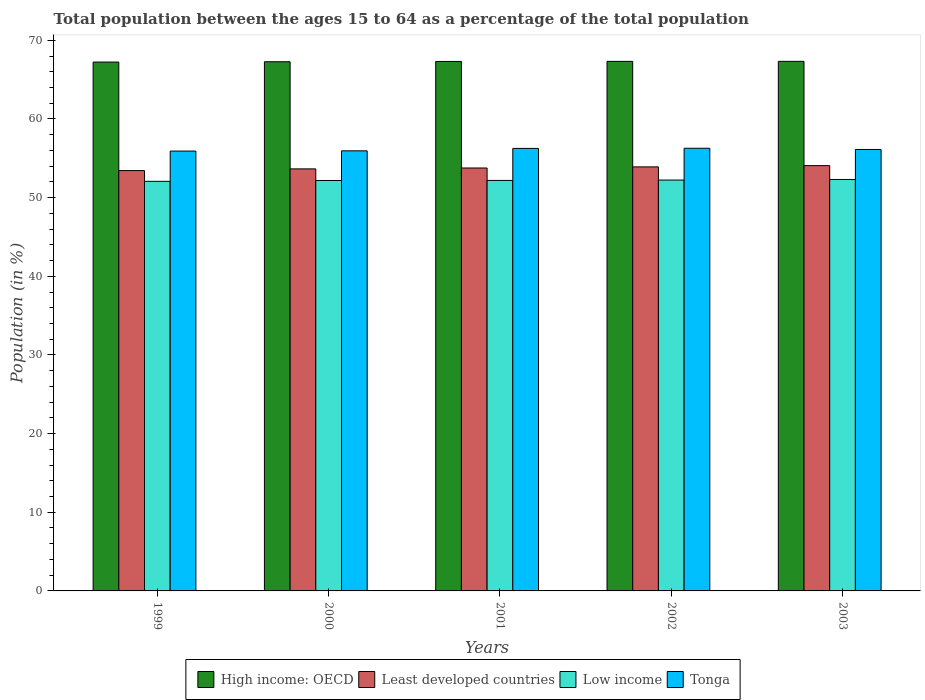How many groups of bars are there?
Offer a terse response. 5. Are the number of bars per tick equal to the number of legend labels?
Make the answer very short. Yes. How many bars are there on the 1st tick from the left?
Offer a very short reply. 4. In how many cases, is the number of bars for a given year not equal to the number of legend labels?
Provide a short and direct response. 0. What is the percentage of the population ages 15 to 64 in High income: OECD in 1999?
Offer a very short reply. 67.24. Across all years, what is the maximum percentage of the population ages 15 to 64 in Tonga?
Make the answer very short. 56.28. Across all years, what is the minimum percentage of the population ages 15 to 64 in Tonga?
Make the answer very short. 55.92. In which year was the percentage of the population ages 15 to 64 in Least developed countries maximum?
Provide a succinct answer. 2003. In which year was the percentage of the population ages 15 to 64 in Low income minimum?
Offer a very short reply. 1999. What is the total percentage of the population ages 15 to 64 in Least developed countries in the graph?
Your answer should be compact. 268.85. What is the difference between the percentage of the population ages 15 to 64 in Tonga in 2000 and that in 2002?
Your response must be concise. -0.33. What is the difference between the percentage of the population ages 15 to 64 in Least developed countries in 2001 and the percentage of the population ages 15 to 64 in Tonga in 2002?
Provide a succinct answer. -2.51. What is the average percentage of the population ages 15 to 64 in High income: OECD per year?
Ensure brevity in your answer.  67.3. In the year 2000, what is the difference between the percentage of the population ages 15 to 64 in Low income and percentage of the population ages 15 to 64 in High income: OECD?
Keep it short and to the point. -15.1. In how many years, is the percentage of the population ages 15 to 64 in Tonga greater than 66?
Ensure brevity in your answer.  0. What is the ratio of the percentage of the population ages 15 to 64 in High income: OECD in 1999 to that in 2000?
Provide a succinct answer. 1. Is the percentage of the population ages 15 to 64 in Tonga in 2002 less than that in 2003?
Keep it short and to the point. No. Is the difference between the percentage of the population ages 15 to 64 in Low income in 2002 and 2003 greater than the difference between the percentage of the population ages 15 to 64 in High income: OECD in 2002 and 2003?
Offer a terse response. No. What is the difference between the highest and the second highest percentage of the population ages 15 to 64 in Tonga?
Your answer should be compact. 0.02. What is the difference between the highest and the lowest percentage of the population ages 15 to 64 in High income: OECD?
Offer a very short reply. 0.09. In how many years, is the percentage of the population ages 15 to 64 in Least developed countries greater than the average percentage of the population ages 15 to 64 in Least developed countries taken over all years?
Your answer should be compact. 2. Is it the case that in every year, the sum of the percentage of the population ages 15 to 64 in Least developed countries and percentage of the population ages 15 to 64 in Tonga is greater than the sum of percentage of the population ages 15 to 64 in Low income and percentage of the population ages 15 to 64 in High income: OECD?
Your answer should be compact. No. What does the 1st bar from the left in 1999 represents?
Ensure brevity in your answer.  High income: OECD. What does the 2nd bar from the right in 2003 represents?
Ensure brevity in your answer.  Low income. What is the difference between two consecutive major ticks on the Y-axis?
Offer a very short reply. 10. Are the values on the major ticks of Y-axis written in scientific E-notation?
Make the answer very short. No. Does the graph contain any zero values?
Ensure brevity in your answer.  No. How many legend labels are there?
Ensure brevity in your answer.  4. How are the legend labels stacked?
Offer a very short reply. Horizontal. What is the title of the graph?
Provide a succinct answer. Total population between the ages 15 to 64 as a percentage of the total population. Does "Liberia" appear as one of the legend labels in the graph?
Offer a very short reply. No. What is the label or title of the X-axis?
Provide a short and direct response. Years. What is the Population (in %) in High income: OECD in 1999?
Make the answer very short. 67.24. What is the Population (in %) in Least developed countries in 1999?
Give a very brief answer. 53.44. What is the Population (in %) in Low income in 1999?
Provide a succinct answer. 52.08. What is the Population (in %) in Tonga in 1999?
Offer a very short reply. 55.92. What is the Population (in %) of High income: OECD in 2000?
Provide a succinct answer. 67.28. What is the Population (in %) of Least developed countries in 2000?
Ensure brevity in your answer.  53.66. What is the Population (in %) in Low income in 2000?
Make the answer very short. 52.18. What is the Population (in %) in Tonga in 2000?
Your answer should be very brief. 55.95. What is the Population (in %) in High income: OECD in 2001?
Provide a short and direct response. 67.31. What is the Population (in %) in Least developed countries in 2001?
Give a very brief answer. 53.77. What is the Population (in %) in Low income in 2001?
Give a very brief answer. 52.19. What is the Population (in %) of Tonga in 2001?
Give a very brief answer. 56.26. What is the Population (in %) of High income: OECD in 2002?
Provide a short and direct response. 67.33. What is the Population (in %) in Least developed countries in 2002?
Your answer should be compact. 53.91. What is the Population (in %) of Low income in 2002?
Keep it short and to the point. 52.24. What is the Population (in %) of Tonga in 2002?
Give a very brief answer. 56.28. What is the Population (in %) in High income: OECD in 2003?
Provide a succinct answer. 67.33. What is the Population (in %) of Least developed countries in 2003?
Your answer should be very brief. 54.07. What is the Population (in %) in Low income in 2003?
Your response must be concise. 52.31. What is the Population (in %) in Tonga in 2003?
Your answer should be compact. 56.12. Across all years, what is the maximum Population (in %) of High income: OECD?
Your answer should be compact. 67.33. Across all years, what is the maximum Population (in %) of Least developed countries?
Make the answer very short. 54.07. Across all years, what is the maximum Population (in %) in Low income?
Offer a terse response. 52.31. Across all years, what is the maximum Population (in %) of Tonga?
Keep it short and to the point. 56.28. Across all years, what is the minimum Population (in %) in High income: OECD?
Ensure brevity in your answer.  67.24. Across all years, what is the minimum Population (in %) of Least developed countries?
Your response must be concise. 53.44. Across all years, what is the minimum Population (in %) of Low income?
Offer a terse response. 52.08. Across all years, what is the minimum Population (in %) in Tonga?
Provide a succinct answer. 55.92. What is the total Population (in %) of High income: OECD in the graph?
Give a very brief answer. 336.49. What is the total Population (in %) in Least developed countries in the graph?
Your answer should be compact. 268.85. What is the total Population (in %) in Low income in the graph?
Ensure brevity in your answer.  260.99. What is the total Population (in %) in Tonga in the graph?
Provide a short and direct response. 280.53. What is the difference between the Population (in %) in High income: OECD in 1999 and that in 2000?
Keep it short and to the point. -0.04. What is the difference between the Population (in %) of Least developed countries in 1999 and that in 2000?
Keep it short and to the point. -0.22. What is the difference between the Population (in %) in Low income in 1999 and that in 2000?
Provide a short and direct response. -0.1. What is the difference between the Population (in %) in Tonga in 1999 and that in 2000?
Offer a terse response. -0.03. What is the difference between the Population (in %) of High income: OECD in 1999 and that in 2001?
Keep it short and to the point. -0.08. What is the difference between the Population (in %) of Least developed countries in 1999 and that in 2001?
Provide a succinct answer. -0.33. What is the difference between the Population (in %) of Low income in 1999 and that in 2001?
Your response must be concise. -0.11. What is the difference between the Population (in %) of Tonga in 1999 and that in 2001?
Provide a short and direct response. -0.34. What is the difference between the Population (in %) of High income: OECD in 1999 and that in 2002?
Keep it short and to the point. -0.09. What is the difference between the Population (in %) of Least developed countries in 1999 and that in 2002?
Give a very brief answer. -0.47. What is the difference between the Population (in %) in Low income in 1999 and that in 2002?
Make the answer very short. -0.16. What is the difference between the Population (in %) in Tonga in 1999 and that in 2002?
Make the answer very short. -0.36. What is the difference between the Population (in %) of High income: OECD in 1999 and that in 2003?
Provide a succinct answer. -0.09. What is the difference between the Population (in %) of Least developed countries in 1999 and that in 2003?
Offer a terse response. -0.63. What is the difference between the Population (in %) of Low income in 1999 and that in 2003?
Ensure brevity in your answer.  -0.23. What is the difference between the Population (in %) in Tonga in 1999 and that in 2003?
Provide a short and direct response. -0.2. What is the difference between the Population (in %) of High income: OECD in 2000 and that in 2001?
Offer a very short reply. -0.04. What is the difference between the Population (in %) of Least developed countries in 2000 and that in 2001?
Keep it short and to the point. -0.11. What is the difference between the Population (in %) in Low income in 2000 and that in 2001?
Provide a short and direct response. -0.01. What is the difference between the Population (in %) in Tonga in 2000 and that in 2001?
Offer a very short reply. -0.31. What is the difference between the Population (in %) in High income: OECD in 2000 and that in 2002?
Keep it short and to the point. -0.05. What is the difference between the Population (in %) of Least developed countries in 2000 and that in 2002?
Your answer should be very brief. -0.26. What is the difference between the Population (in %) of Low income in 2000 and that in 2002?
Your answer should be compact. -0.06. What is the difference between the Population (in %) in Tonga in 2000 and that in 2002?
Give a very brief answer. -0.33. What is the difference between the Population (in %) in High income: OECD in 2000 and that in 2003?
Provide a succinct answer. -0.05. What is the difference between the Population (in %) in Least developed countries in 2000 and that in 2003?
Offer a terse response. -0.42. What is the difference between the Population (in %) in Low income in 2000 and that in 2003?
Give a very brief answer. -0.13. What is the difference between the Population (in %) of Tonga in 2000 and that in 2003?
Ensure brevity in your answer.  -0.17. What is the difference between the Population (in %) in High income: OECD in 2001 and that in 2002?
Provide a succinct answer. -0.01. What is the difference between the Population (in %) in Least developed countries in 2001 and that in 2002?
Ensure brevity in your answer.  -0.14. What is the difference between the Population (in %) of Low income in 2001 and that in 2002?
Offer a terse response. -0.05. What is the difference between the Population (in %) of Tonga in 2001 and that in 2002?
Your response must be concise. -0.02. What is the difference between the Population (in %) of High income: OECD in 2001 and that in 2003?
Provide a succinct answer. -0.01. What is the difference between the Population (in %) in Least developed countries in 2001 and that in 2003?
Provide a succinct answer. -0.3. What is the difference between the Population (in %) in Low income in 2001 and that in 2003?
Ensure brevity in your answer.  -0.12. What is the difference between the Population (in %) of Tonga in 2001 and that in 2003?
Your answer should be very brief. 0.14. What is the difference between the Population (in %) of High income: OECD in 2002 and that in 2003?
Your answer should be very brief. -0. What is the difference between the Population (in %) in Least developed countries in 2002 and that in 2003?
Offer a very short reply. -0.16. What is the difference between the Population (in %) in Low income in 2002 and that in 2003?
Offer a very short reply. -0.07. What is the difference between the Population (in %) in Tonga in 2002 and that in 2003?
Your answer should be very brief. 0.15. What is the difference between the Population (in %) in High income: OECD in 1999 and the Population (in %) in Least developed countries in 2000?
Your response must be concise. 13.58. What is the difference between the Population (in %) in High income: OECD in 1999 and the Population (in %) in Low income in 2000?
Offer a very short reply. 15.06. What is the difference between the Population (in %) of High income: OECD in 1999 and the Population (in %) of Tonga in 2000?
Provide a succinct answer. 11.29. What is the difference between the Population (in %) of Least developed countries in 1999 and the Population (in %) of Low income in 2000?
Give a very brief answer. 1.26. What is the difference between the Population (in %) in Least developed countries in 1999 and the Population (in %) in Tonga in 2000?
Ensure brevity in your answer.  -2.51. What is the difference between the Population (in %) of Low income in 1999 and the Population (in %) of Tonga in 2000?
Provide a short and direct response. -3.87. What is the difference between the Population (in %) in High income: OECD in 1999 and the Population (in %) in Least developed countries in 2001?
Offer a very short reply. 13.47. What is the difference between the Population (in %) of High income: OECD in 1999 and the Population (in %) of Low income in 2001?
Give a very brief answer. 15.05. What is the difference between the Population (in %) of High income: OECD in 1999 and the Population (in %) of Tonga in 2001?
Your answer should be compact. 10.98. What is the difference between the Population (in %) in Least developed countries in 1999 and the Population (in %) in Low income in 2001?
Your response must be concise. 1.25. What is the difference between the Population (in %) of Least developed countries in 1999 and the Population (in %) of Tonga in 2001?
Ensure brevity in your answer.  -2.82. What is the difference between the Population (in %) of Low income in 1999 and the Population (in %) of Tonga in 2001?
Your answer should be very brief. -4.18. What is the difference between the Population (in %) in High income: OECD in 1999 and the Population (in %) in Least developed countries in 2002?
Your answer should be very brief. 13.33. What is the difference between the Population (in %) in High income: OECD in 1999 and the Population (in %) in Low income in 2002?
Your answer should be compact. 15. What is the difference between the Population (in %) in High income: OECD in 1999 and the Population (in %) in Tonga in 2002?
Give a very brief answer. 10.96. What is the difference between the Population (in %) of Least developed countries in 1999 and the Population (in %) of Low income in 2002?
Give a very brief answer. 1.2. What is the difference between the Population (in %) of Least developed countries in 1999 and the Population (in %) of Tonga in 2002?
Your response must be concise. -2.84. What is the difference between the Population (in %) of Low income in 1999 and the Population (in %) of Tonga in 2002?
Keep it short and to the point. -4.2. What is the difference between the Population (in %) in High income: OECD in 1999 and the Population (in %) in Least developed countries in 2003?
Provide a succinct answer. 13.17. What is the difference between the Population (in %) in High income: OECD in 1999 and the Population (in %) in Low income in 2003?
Offer a very short reply. 14.93. What is the difference between the Population (in %) of High income: OECD in 1999 and the Population (in %) of Tonga in 2003?
Offer a very short reply. 11.12. What is the difference between the Population (in %) of Least developed countries in 1999 and the Population (in %) of Low income in 2003?
Make the answer very short. 1.13. What is the difference between the Population (in %) in Least developed countries in 1999 and the Population (in %) in Tonga in 2003?
Ensure brevity in your answer.  -2.68. What is the difference between the Population (in %) of Low income in 1999 and the Population (in %) of Tonga in 2003?
Ensure brevity in your answer.  -4.05. What is the difference between the Population (in %) in High income: OECD in 2000 and the Population (in %) in Least developed countries in 2001?
Your answer should be very brief. 13.51. What is the difference between the Population (in %) of High income: OECD in 2000 and the Population (in %) of Low income in 2001?
Offer a terse response. 15.09. What is the difference between the Population (in %) in High income: OECD in 2000 and the Population (in %) in Tonga in 2001?
Offer a terse response. 11.02. What is the difference between the Population (in %) of Least developed countries in 2000 and the Population (in %) of Low income in 2001?
Ensure brevity in your answer.  1.47. What is the difference between the Population (in %) of Least developed countries in 2000 and the Population (in %) of Tonga in 2001?
Provide a succinct answer. -2.6. What is the difference between the Population (in %) of Low income in 2000 and the Population (in %) of Tonga in 2001?
Ensure brevity in your answer.  -4.08. What is the difference between the Population (in %) in High income: OECD in 2000 and the Population (in %) in Least developed countries in 2002?
Keep it short and to the point. 13.37. What is the difference between the Population (in %) of High income: OECD in 2000 and the Population (in %) of Low income in 2002?
Your response must be concise. 15.04. What is the difference between the Population (in %) in High income: OECD in 2000 and the Population (in %) in Tonga in 2002?
Provide a succinct answer. 11. What is the difference between the Population (in %) of Least developed countries in 2000 and the Population (in %) of Low income in 2002?
Provide a short and direct response. 1.42. What is the difference between the Population (in %) in Least developed countries in 2000 and the Population (in %) in Tonga in 2002?
Offer a very short reply. -2.62. What is the difference between the Population (in %) in High income: OECD in 2000 and the Population (in %) in Least developed countries in 2003?
Ensure brevity in your answer.  13.21. What is the difference between the Population (in %) of High income: OECD in 2000 and the Population (in %) of Low income in 2003?
Offer a terse response. 14.97. What is the difference between the Population (in %) in High income: OECD in 2000 and the Population (in %) in Tonga in 2003?
Make the answer very short. 11.16. What is the difference between the Population (in %) of Least developed countries in 2000 and the Population (in %) of Low income in 2003?
Offer a very short reply. 1.35. What is the difference between the Population (in %) of Least developed countries in 2000 and the Population (in %) of Tonga in 2003?
Ensure brevity in your answer.  -2.47. What is the difference between the Population (in %) of Low income in 2000 and the Population (in %) of Tonga in 2003?
Give a very brief answer. -3.95. What is the difference between the Population (in %) in High income: OECD in 2001 and the Population (in %) in Least developed countries in 2002?
Provide a short and direct response. 13.4. What is the difference between the Population (in %) in High income: OECD in 2001 and the Population (in %) in Low income in 2002?
Your answer should be very brief. 15.08. What is the difference between the Population (in %) in High income: OECD in 2001 and the Population (in %) in Tonga in 2002?
Make the answer very short. 11.04. What is the difference between the Population (in %) in Least developed countries in 2001 and the Population (in %) in Low income in 2002?
Give a very brief answer. 1.53. What is the difference between the Population (in %) in Least developed countries in 2001 and the Population (in %) in Tonga in 2002?
Your response must be concise. -2.51. What is the difference between the Population (in %) of Low income in 2001 and the Population (in %) of Tonga in 2002?
Your answer should be very brief. -4.09. What is the difference between the Population (in %) of High income: OECD in 2001 and the Population (in %) of Least developed countries in 2003?
Provide a succinct answer. 13.24. What is the difference between the Population (in %) in High income: OECD in 2001 and the Population (in %) in Low income in 2003?
Your response must be concise. 15.01. What is the difference between the Population (in %) in High income: OECD in 2001 and the Population (in %) in Tonga in 2003?
Offer a very short reply. 11.19. What is the difference between the Population (in %) in Least developed countries in 2001 and the Population (in %) in Low income in 2003?
Your response must be concise. 1.46. What is the difference between the Population (in %) of Least developed countries in 2001 and the Population (in %) of Tonga in 2003?
Give a very brief answer. -2.35. What is the difference between the Population (in %) in Low income in 2001 and the Population (in %) in Tonga in 2003?
Make the answer very short. -3.94. What is the difference between the Population (in %) in High income: OECD in 2002 and the Population (in %) in Least developed countries in 2003?
Give a very brief answer. 13.25. What is the difference between the Population (in %) of High income: OECD in 2002 and the Population (in %) of Low income in 2003?
Your answer should be very brief. 15.02. What is the difference between the Population (in %) of High income: OECD in 2002 and the Population (in %) of Tonga in 2003?
Make the answer very short. 11.2. What is the difference between the Population (in %) in Least developed countries in 2002 and the Population (in %) in Low income in 2003?
Keep it short and to the point. 1.6. What is the difference between the Population (in %) in Least developed countries in 2002 and the Population (in %) in Tonga in 2003?
Offer a terse response. -2.21. What is the difference between the Population (in %) of Low income in 2002 and the Population (in %) of Tonga in 2003?
Offer a terse response. -3.89. What is the average Population (in %) in High income: OECD per year?
Your answer should be very brief. 67.3. What is the average Population (in %) in Least developed countries per year?
Ensure brevity in your answer.  53.77. What is the average Population (in %) in Low income per year?
Your answer should be compact. 52.2. What is the average Population (in %) in Tonga per year?
Ensure brevity in your answer.  56.11. In the year 1999, what is the difference between the Population (in %) of High income: OECD and Population (in %) of Least developed countries?
Keep it short and to the point. 13.8. In the year 1999, what is the difference between the Population (in %) in High income: OECD and Population (in %) in Low income?
Your answer should be compact. 15.16. In the year 1999, what is the difference between the Population (in %) in High income: OECD and Population (in %) in Tonga?
Keep it short and to the point. 11.32. In the year 1999, what is the difference between the Population (in %) in Least developed countries and Population (in %) in Low income?
Offer a terse response. 1.36. In the year 1999, what is the difference between the Population (in %) of Least developed countries and Population (in %) of Tonga?
Your answer should be compact. -2.48. In the year 1999, what is the difference between the Population (in %) of Low income and Population (in %) of Tonga?
Make the answer very short. -3.85. In the year 2000, what is the difference between the Population (in %) of High income: OECD and Population (in %) of Least developed countries?
Ensure brevity in your answer.  13.62. In the year 2000, what is the difference between the Population (in %) in High income: OECD and Population (in %) in Low income?
Provide a succinct answer. 15.1. In the year 2000, what is the difference between the Population (in %) of High income: OECD and Population (in %) of Tonga?
Your response must be concise. 11.33. In the year 2000, what is the difference between the Population (in %) of Least developed countries and Population (in %) of Low income?
Offer a very short reply. 1.48. In the year 2000, what is the difference between the Population (in %) in Least developed countries and Population (in %) in Tonga?
Ensure brevity in your answer.  -2.29. In the year 2000, what is the difference between the Population (in %) of Low income and Population (in %) of Tonga?
Offer a very short reply. -3.77. In the year 2001, what is the difference between the Population (in %) of High income: OECD and Population (in %) of Least developed countries?
Ensure brevity in your answer.  13.55. In the year 2001, what is the difference between the Population (in %) of High income: OECD and Population (in %) of Low income?
Your response must be concise. 15.13. In the year 2001, what is the difference between the Population (in %) in High income: OECD and Population (in %) in Tonga?
Provide a short and direct response. 11.06. In the year 2001, what is the difference between the Population (in %) of Least developed countries and Population (in %) of Low income?
Keep it short and to the point. 1.58. In the year 2001, what is the difference between the Population (in %) in Least developed countries and Population (in %) in Tonga?
Provide a succinct answer. -2.49. In the year 2001, what is the difference between the Population (in %) in Low income and Population (in %) in Tonga?
Offer a very short reply. -4.07. In the year 2002, what is the difference between the Population (in %) of High income: OECD and Population (in %) of Least developed countries?
Your answer should be very brief. 13.41. In the year 2002, what is the difference between the Population (in %) in High income: OECD and Population (in %) in Low income?
Offer a terse response. 15.09. In the year 2002, what is the difference between the Population (in %) in High income: OECD and Population (in %) in Tonga?
Your response must be concise. 11.05. In the year 2002, what is the difference between the Population (in %) in Least developed countries and Population (in %) in Low income?
Ensure brevity in your answer.  1.68. In the year 2002, what is the difference between the Population (in %) of Least developed countries and Population (in %) of Tonga?
Provide a short and direct response. -2.37. In the year 2002, what is the difference between the Population (in %) in Low income and Population (in %) in Tonga?
Offer a terse response. -4.04. In the year 2003, what is the difference between the Population (in %) in High income: OECD and Population (in %) in Least developed countries?
Offer a terse response. 13.25. In the year 2003, what is the difference between the Population (in %) in High income: OECD and Population (in %) in Low income?
Ensure brevity in your answer.  15.02. In the year 2003, what is the difference between the Population (in %) of High income: OECD and Population (in %) of Tonga?
Make the answer very short. 11.2. In the year 2003, what is the difference between the Population (in %) in Least developed countries and Population (in %) in Low income?
Provide a short and direct response. 1.76. In the year 2003, what is the difference between the Population (in %) in Least developed countries and Population (in %) in Tonga?
Provide a succinct answer. -2.05. In the year 2003, what is the difference between the Population (in %) in Low income and Population (in %) in Tonga?
Provide a short and direct response. -3.81. What is the ratio of the Population (in %) in Least developed countries in 1999 to that in 2000?
Give a very brief answer. 1. What is the ratio of the Population (in %) of High income: OECD in 1999 to that in 2001?
Give a very brief answer. 1. What is the ratio of the Population (in %) in High income: OECD in 1999 to that in 2002?
Your answer should be compact. 1. What is the ratio of the Population (in %) of Least developed countries in 1999 to that in 2002?
Give a very brief answer. 0.99. What is the ratio of the Population (in %) in Low income in 1999 to that in 2002?
Your answer should be compact. 1. What is the ratio of the Population (in %) of High income: OECD in 1999 to that in 2003?
Your answer should be compact. 1. What is the ratio of the Population (in %) of Least developed countries in 1999 to that in 2003?
Give a very brief answer. 0.99. What is the ratio of the Population (in %) in Low income in 1999 to that in 2003?
Give a very brief answer. 1. What is the ratio of the Population (in %) in Tonga in 1999 to that in 2003?
Keep it short and to the point. 1. What is the ratio of the Population (in %) of High income: OECD in 2000 to that in 2002?
Offer a terse response. 1. What is the ratio of the Population (in %) of Low income in 2000 to that in 2002?
Ensure brevity in your answer.  1. What is the ratio of the Population (in %) in Least developed countries in 2000 to that in 2003?
Make the answer very short. 0.99. What is the ratio of the Population (in %) of Low income in 2000 to that in 2003?
Ensure brevity in your answer.  1. What is the ratio of the Population (in %) in High income: OECD in 2001 to that in 2002?
Offer a terse response. 1. What is the ratio of the Population (in %) in Least developed countries in 2001 to that in 2002?
Make the answer very short. 1. What is the ratio of the Population (in %) in Least developed countries in 2001 to that in 2003?
Provide a succinct answer. 0.99. What is the ratio of the Population (in %) of Tonga in 2001 to that in 2003?
Offer a terse response. 1. What is the ratio of the Population (in %) in Low income in 2002 to that in 2003?
Keep it short and to the point. 1. What is the difference between the highest and the second highest Population (in %) in High income: OECD?
Give a very brief answer. 0. What is the difference between the highest and the second highest Population (in %) of Least developed countries?
Keep it short and to the point. 0.16. What is the difference between the highest and the second highest Population (in %) of Low income?
Offer a very short reply. 0.07. What is the difference between the highest and the second highest Population (in %) in Tonga?
Your answer should be very brief. 0.02. What is the difference between the highest and the lowest Population (in %) in High income: OECD?
Provide a succinct answer. 0.09. What is the difference between the highest and the lowest Population (in %) in Least developed countries?
Offer a very short reply. 0.63. What is the difference between the highest and the lowest Population (in %) in Low income?
Ensure brevity in your answer.  0.23. What is the difference between the highest and the lowest Population (in %) of Tonga?
Provide a succinct answer. 0.36. 